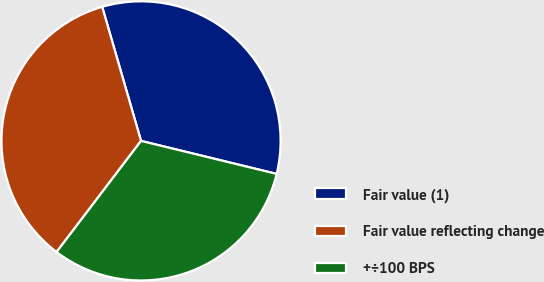Convert chart. <chart><loc_0><loc_0><loc_500><loc_500><pie_chart><fcel>Fair value (1)<fcel>Fair value reflecting change<fcel>+÷100 BPS<nl><fcel>33.29%<fcel>35.17%<fcel>31.54%<nl></chart> 